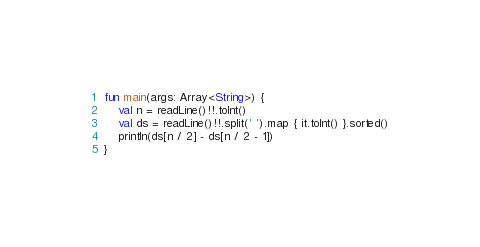Convert code to text. <code><loc_0><loc_0><loc_500><loc_500><_Kotlin_>fun main(args: Array<String>) {
    val n = readLine()!!.toInt()
    val ds = readLine()!!.split(' ').map { it.toInt() }.sorted()
    println(ds[n / 2] - ds[n / 2 - 1])
}</code> 